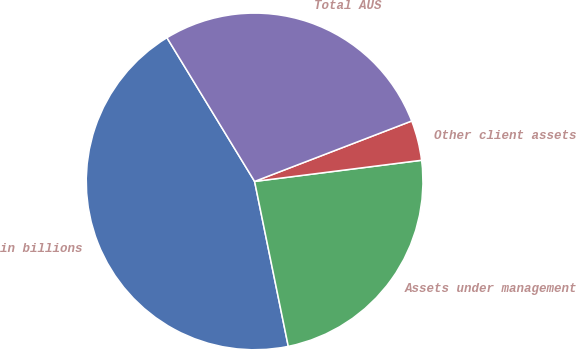<chart> <loc_0><loc_0><loc_500><loc_500><pie_chart><fcel>in billions<fcel>Assets under management<fcel>Other client assets<fcel>Total AUS<nl><fcel>44.49%<fcel>23.8%<fcel>3.84%<fcel>27.87%<nl></chart> 